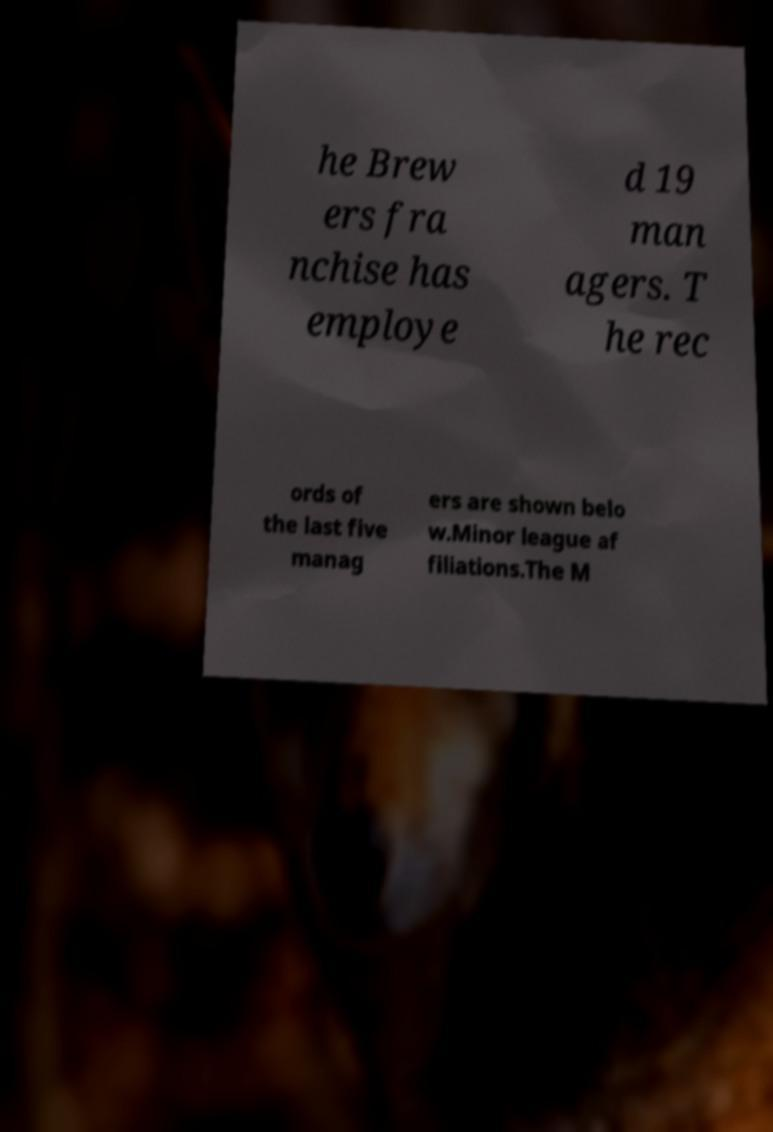Could you assist in decoding the text presented in this image and type it out clearly? he Brew ers fra nchise has employe d 19 man agers. T he rec ords of the last five manag ers are shown belo w.Minor league af filiations.The M 